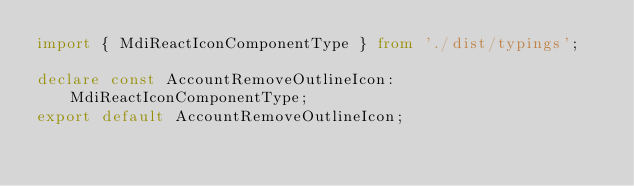Convert code to text. <code><loc_0><loc_0><loc_500><loc_500><_TypeScript_>import { MdiReactIconComponentType } from './dist/typings';

declare const AccountRemoveOutlineIcon: MdiReactIconComponentType;
export default AccountRemoveOutlineIcon;
</code> 